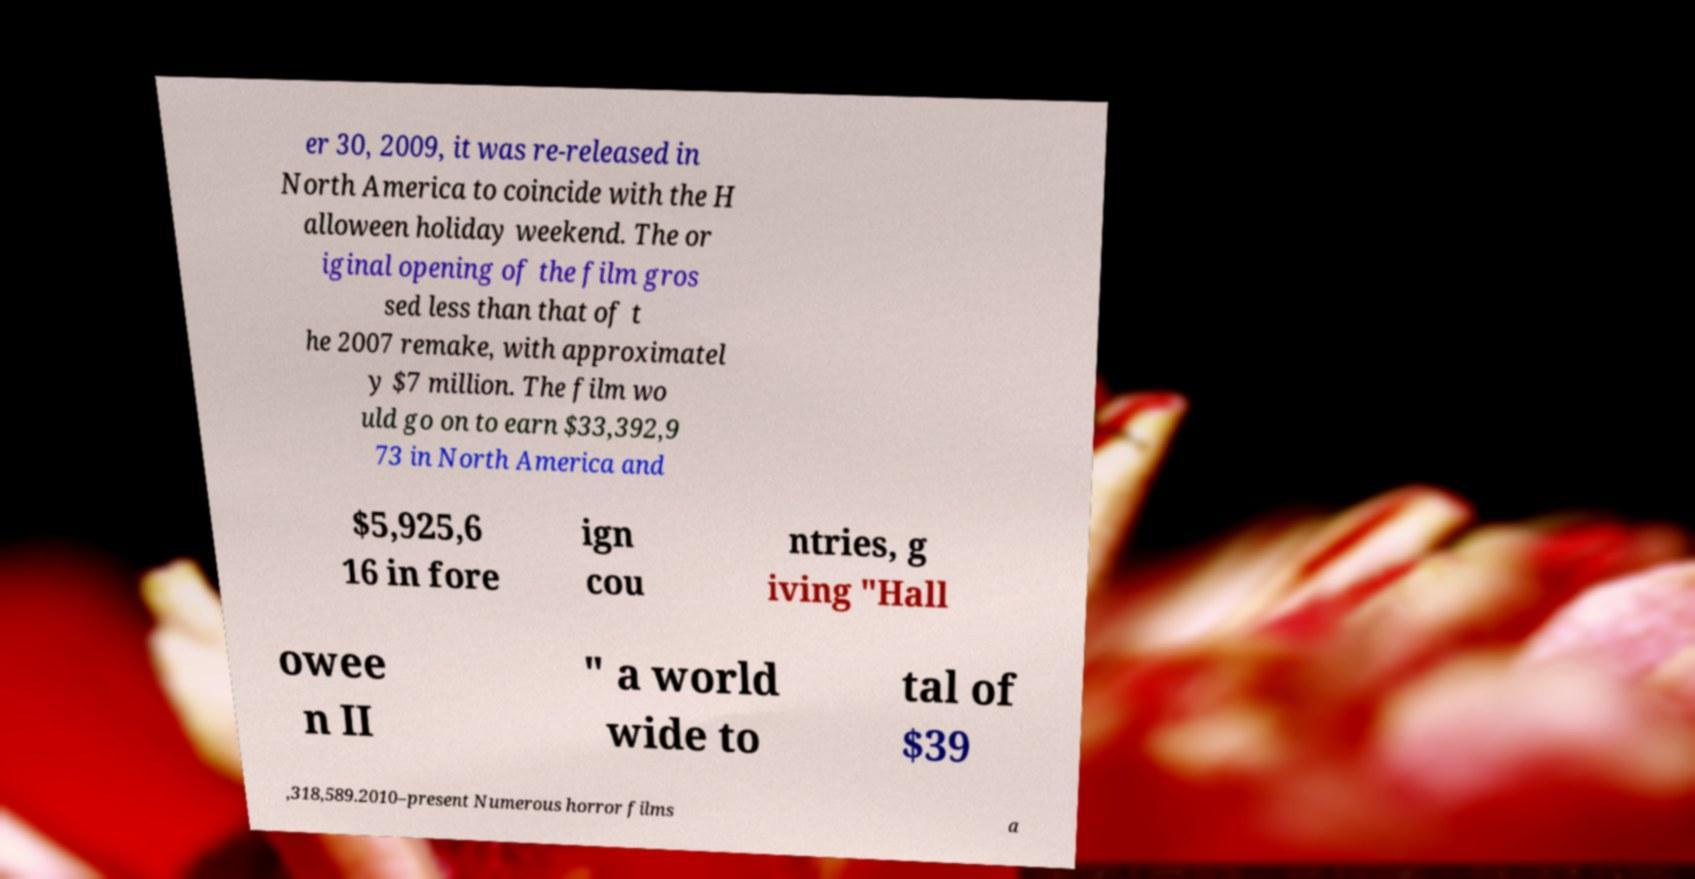Could you assist in decoding the text presented in this image and type it out clearly? er 30, 2009, it was re-released in North America to coincide with the H alloween holiday weekend. The or iginal opening of the film gros sed less than that of t he 2007 remake, with approximatel y $7 million. The film wo uld go on to earn $33,392,9 73 in North America and $5,925,6 16 in fore ign cou ntries, g iving "Hall owee n II " a world wide to tal of $39 ,318,589.2010–present Numerous horror films a 